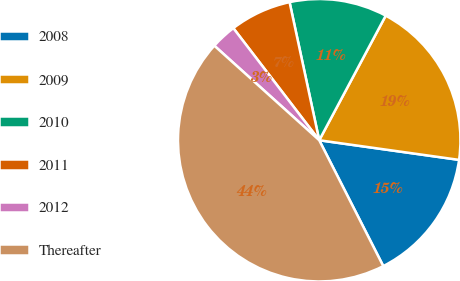Convert chart. <chart><loc_0><loc_0><loc_500><loc_500><pie_chart><fcel>2008<fcel>2009<fcel>2010<fcel>2011<fcel>2012<fcel>Thereafter<nl><fcel>15.29%<fcel>19.42%<fcel>11.17%<fcel>7.04%<fcel>2.92%<fcel>44.17%<nl></chart> 